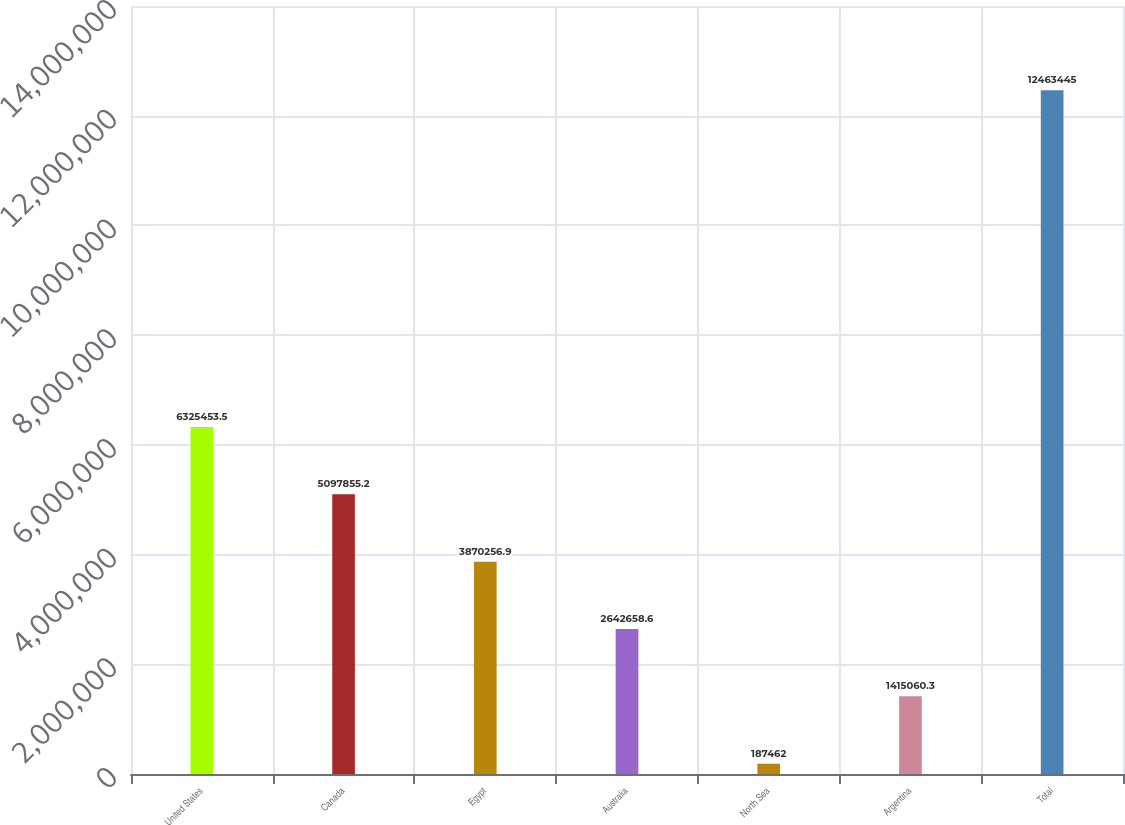<chart> <loc_0><loc_0><loc_500><loc_500><bar_chart><fcel>United States<fcel>Canada<fcel>Egypt<fcel>Australia<fcel>North Sea<fcel>Argentina<fcel>Total<nl><fcel>6.32545e+06<fcel>5.09786e+06<fcel>3.87026e+06<fcel>2.64266e+06<fcel>187462<fcel>1.41506e+06<fcel>1.24634e+07<nl></chart> 